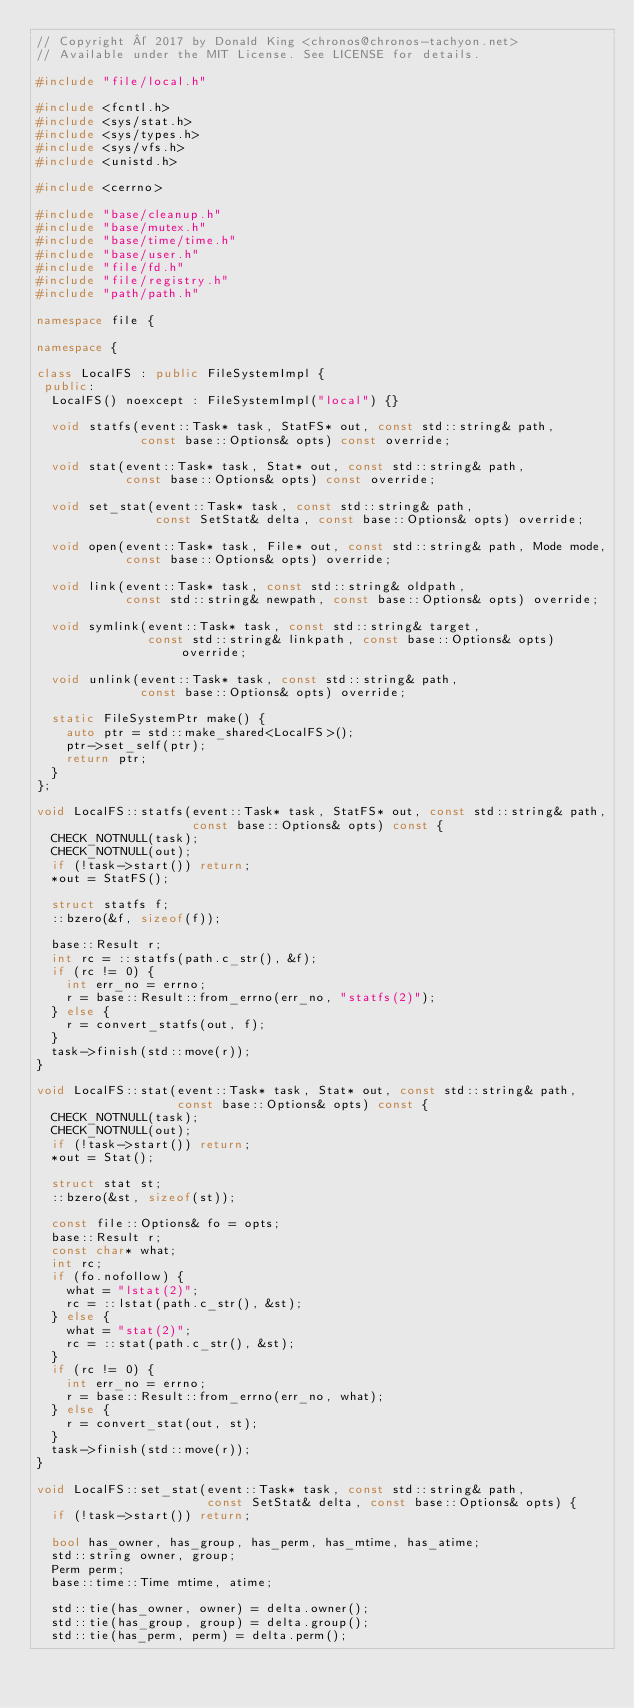Convert code to text. <code><loc_0><loc_0><loc_500><loc_500><_C++_>// Copyright © 2017 by Donald King <chronos@chronos-tachyon.net>
// Available under the MIT License. See LICENSE for details.

#include "file/local.h"

#include <fcntl.h>
#include <sys/stat.h>
#include <sys/types.h>
#include <sys/vfs.h>
#include <unistd.h>

#include <cerrno>

#include "base/cleanup.h"
#include "base/mutex.h"
#include "base/time/time.h"
#include "base/user.h"
#include "file/fd.h"
#include "file/registry.h"
#include "path/path.h"

namespace file {

namespace {

class LocalFS : public FileSystemImpl {
 public:
  LocalFS() noexcept : FileSystemImpl("local") {}

  void statfs(event::Task* task, StatFS* out, const std::string& path,
              const base::Options& opts) const override;

  void stat(event::Task* task, Stat* out, const std::string& path,
            const base::Options& opts) const override;

  void set_stat(event::Task* task, const std::string& path,
                const SetStat& delta, const base::Options& opts) override;

  void open(event::Task* task, File* out, const std::string& path, Mode mode,
            const base::Options& opts) override;

  void link(event::Task* task, const std::string& oldpath,
            const std::string& newpath, const base::Options& opts) override;

  void symlink(event::Task* task, const std::string& target,
               const std::string& linkpath, const base::Options& opts) override;

  void unlink(event::Task* task, const std::string& path,
              const base::Options& opts) override;

  static FileSystemPtr make() {
    auto ptr = std::make_shared<LocalFS>();
    ptr->set_self(ptr);
    return ptr;
  }
};

void LocalFS::statfs(event::Task* task, StatFS* out, const std::string& path,
                     const base::Options& opts) const {
  CHECK_NOTNULL(task);
  CHECK_NOTNULL(out);
  if (!task->start()) return;
  *out = StatFS();

  struct statfs f;
  ::bzero(&f, sizeof(f));

  base::Result r;
  int rc = ::statfs(path.c_str(), &f);
  if (rc != 0) {
    int err_no = errno;
    r = base::Result::from_errno(err_no, "statfs(2)");
  } else {
    r = convert_statfs(out, f);
  }
  task->finish(std::move(r));
}

void LocalFS::stat(event::Task* task, Stat* out, const std::string& path,
                   const base::Options& opts) const {
  CHECK_NOTNULL(task);
  CHECK_NOTNULL(out);
  if (!task->start()) return;
  *out = Stat();

  struct stat st;
  ::bzero(&st, sizeof(st));

  const file::Options& fo = opts;
  base::Result r;
  const char* what;
  int rc;
  if (fo.nofollow) {
    what = "lstat(2)";
    rc = ::lstat(path.c_str(), &st);
  } else {
    what = "stat(2)";
    rc = ::stat(path.c_str(), &st);
  }
  if (rc != 0) {
    int err_no = errno;
    r = base::Result::from_errno(err_no, what);
  } else {
    r = convert_stat(out, st);
  }
  task->finish(std::move(r));
}

void LocalFS::set_stat(event::Task* task, const std::string& path,
                       const SetStat& delta, const base::Options& opts) {
  if (!task->start()) return;

  bool has_owner, has_group, has_perm, has_mtime, has_atime;
  std::string owner, group;
  Perm perm;
  base::time::Time mtime, atime;

  std::tie(has_owner, owner) = delta.owner();
  std::tie(has_group, group) = delta.group();
  std::tie(has_perm, perm) = delta.perm();</code> 